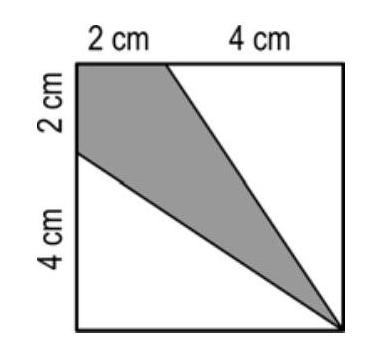Can you calculate the area of the grey region in square centimeters? The total area of the square is 8 square centimeters (2 cm x 4 cm). Since the grey region constitutes one-third of this area, it is approximately 2.67 square centimeters. 